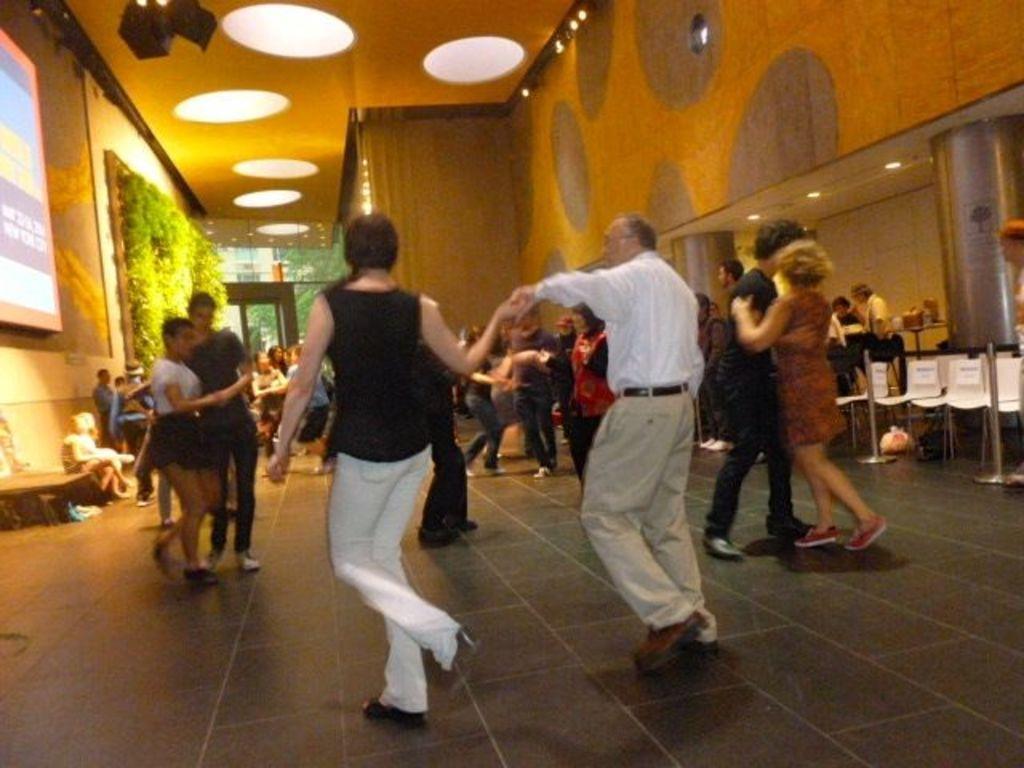How would you summarize this image in a sentence or two? In the picture we can see some people are dancing on the floor, and besides to it, we can see some people are standing near the desks and in the wall we can see a screen and some plant decorations and in the background, we can see some people are sitting on the chairs near the tables, and to the ceiling we can see some lights. 